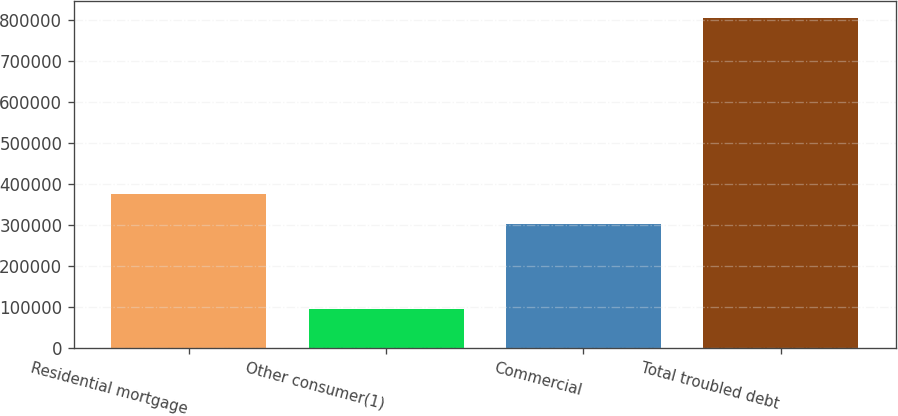<chart> <loc_0><loc_0><loc_500><loc_500><bar_chart><fcel>Residential mortgage<fcel>Other consumer(1)<fcel>Commercial<fcel>Total troubled debt<nl><fcel>375050<fcel>94905<fcel>303975<fcel>805650<nl></chart> 